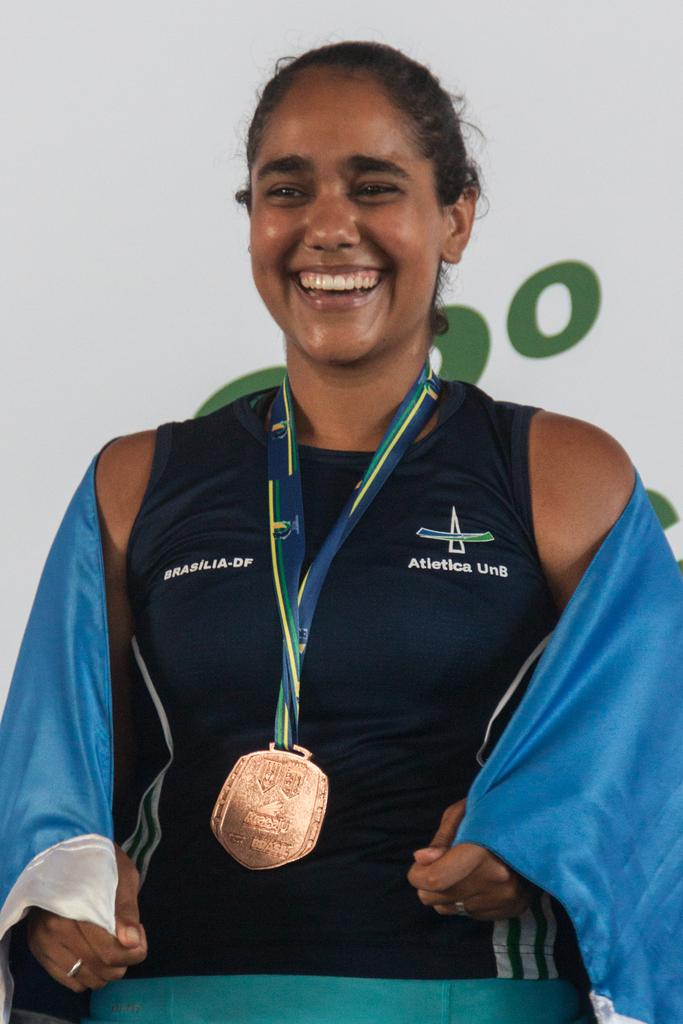Who or what is present in the image? There is a person in the image. What is the person's facial expression? The person has a smile on her face. What can be seen in the background of the image? There is a banner in the background of the image. How many fairies are flying around the person in the image? There are no fairies present in the image. What type of eggs are being cooked on the pan in the image? There is no pan or eggs present in the image. 